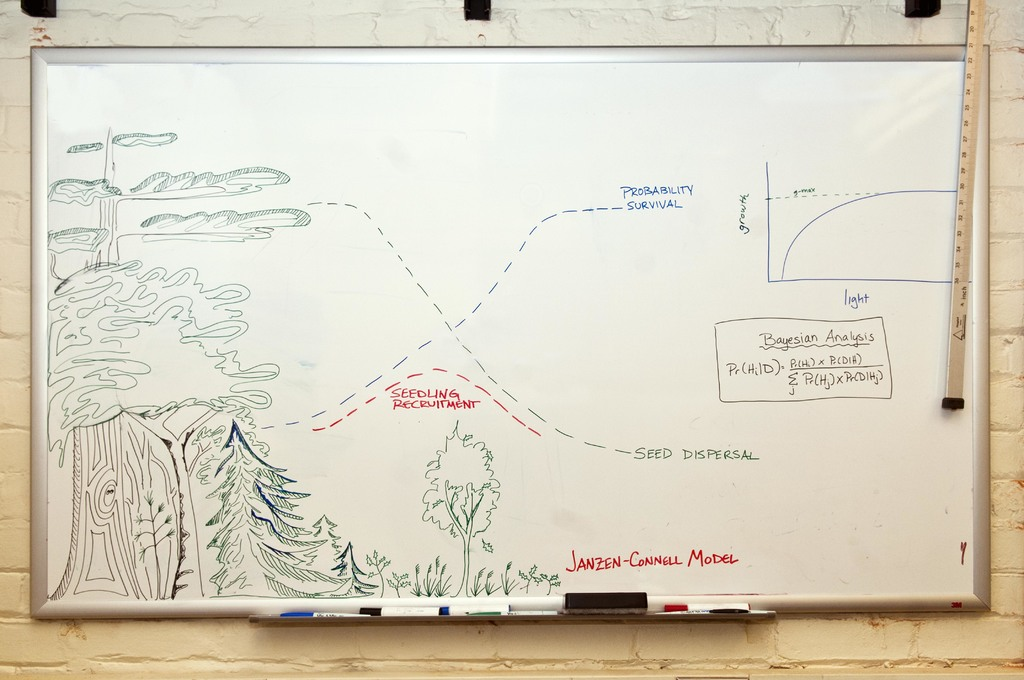How does the graph on the whiteboard relate to the overall explanation of the Janzen-Connell model? The graph depicted on the whiteboard illustrates a survival probability curve of seedlings as a function of their distance from the parent tree. It likely represents a declining slope where survival probability increases with increasing distance. This graphical representation is integral to the Janzen-Connell model as it visually summarizes the hypothesis that seed survival and seedling recruitment are negatively affected by proximity to the parent, thus reinforcing the model's core premise through visual data. This graph not only aids in comprehending the model but further serves as a practical demonstration of how ecological data can be analyzed and visualized scientifically. 